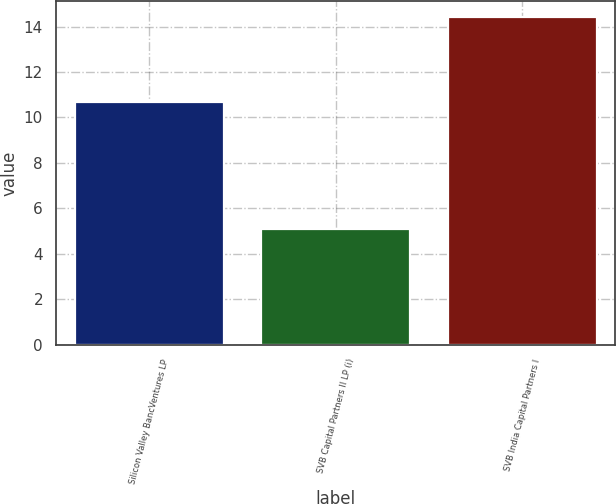Convert chart to OTSL. <chart><loc_0><loc_0><loc_500><loc_500><bar_chart><fcel>Silicon Valley BancVentures LP<fcel>SVB Capital Partners II LP (i)<fcel>SVB India Capital Partners I<nl><fcel>10.7<fcel>5.1<fcel>14.4<nl></chart> 